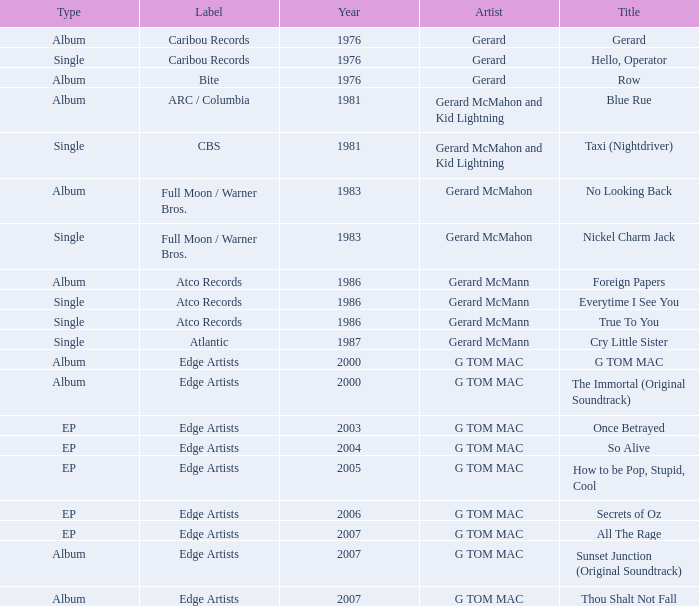Help me parse the entirety of this table. {'header': ['Type', 'Label', 'Year', 'Artist', 'Title'], 'rows': [['Album', 'Caribou Records', '1976', 'Gerard', 'Gerard'], ['Single', 'Caribou Records', '1976', 'Gerard', 'Hello, Operator'], ['Album', 'Bite', '1976', 'Gerard', 'Row'], ['Album', 'ARC / Columbia', '1981', 'Gerard McMahon and Kid Lightning', 'Blue Rue'], ['Single', 'CBS', '1981', 'Gerard McMahon and Kid Lightning', 'Taxi (Nightdriver)'], ['Album', 'Full Moon / Warner Bros.', '1983', 'Gerard McMahon', 'No Looking Back'], ['Single', 'Full Moon / Warner Bros.', '1983', 'Gerard McMahon', 'Nickel Charm Jack'], ['Album', 'Atco Records', '1986', 'Gerard McMann', 'Foreign Papers'], ['Single', 'Atco Records', '1986', 'Gerard McMann', 'Everytime I See You'], ['Single', 'Atco Records', '1986', 'Gerard McMann', 'True To You'], ['Single', 'Atlantic', '1987', 'Gerard McMann', 'Cry Little Sister'], ['Album', 'Edge Artists', '2000', 'G TOM MAC', 'G TOM MAC'], ['Album', 'Edge Artists', '2000', 'G TOM MAC', 'The Immortal (Original Soundtrack)'], ['EP', 'Edge Artists', '2003', 'G TOM MAC', 'Once Betrayed'], ['EP', 'Edge Artists', '2004', 'G TOM MAC', 'So Alive'], ['EP', 'Edge Artists', '2005', 'G TOM MAC', 'How to be Pop, Stupid, Cool'], ['EP', 'Edge Artists', '2006', 'G TOM MAC', 'Secrets of Oz'], ['EP', 'Edge Artists', '2007', 'G TOM MAC', 'All The Rage'], ['Album', 'Edge Artists', '2007', 'G TOM MAC', 'Sunset Junction (Original Soundtrack)'], ['Album', 'Edge Artists', '2007', 'G TOM MAC', 'Thou Shalt Not Fall']]} Name the Year which has a Label of atco records and a Type of album? Question 2 1986.0. 